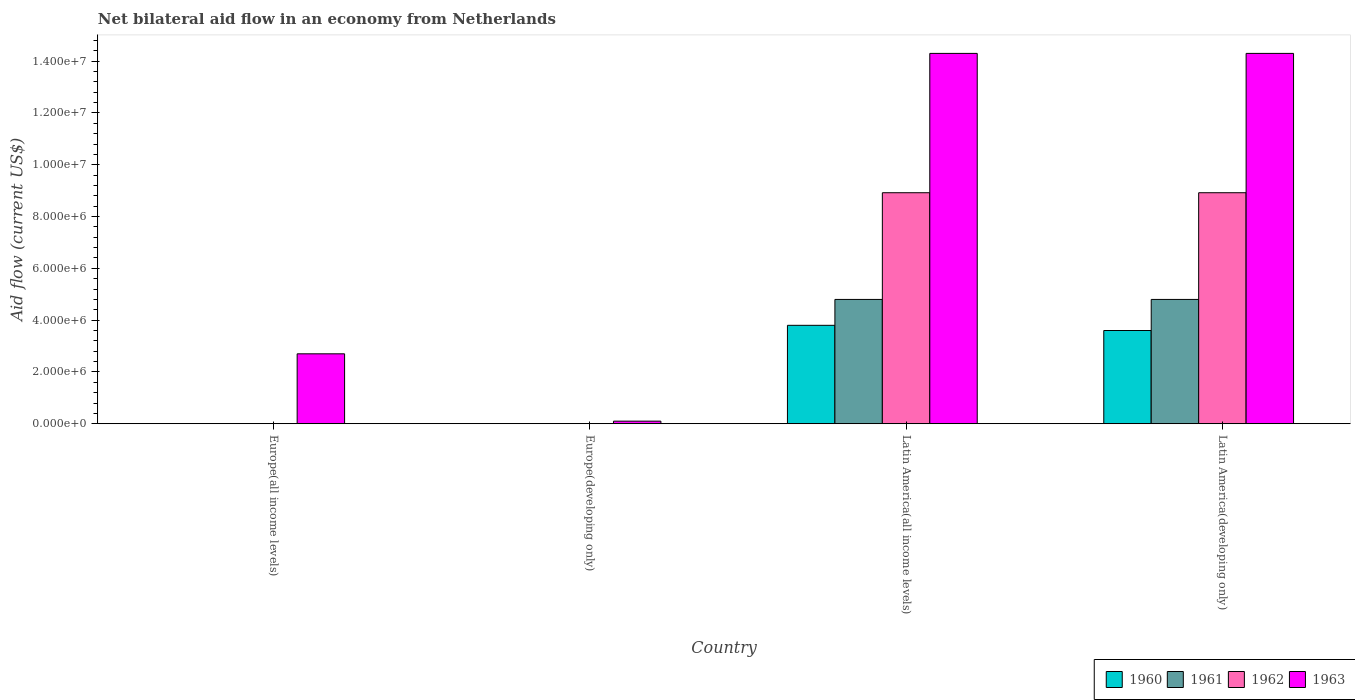Are the number of bars per tick equal to the number of legend labels?
Offer a terse response. No. What is the label of the 2nd group of bars from the left?
Offer a terse response. Europe(developing only). In how many cases, is the number of bars for a given country not equal to the number of legend labels?
Make the answer very short. 2. What is the net bilateral aid flow in 1962 in Latin America(all income levels)?
Give a very brief answer. 8.92e+06. Across all countries, what is the maximum net bilateral aid flow in 1962?
Offer a very short reply. 8.92e+06. In which country was the net bilateral aid flow in 1962 maximum?
Offer a terse response. Latin America(all income levels). What is the total net bilateral aid flow in 1963 in the graph?
Your answer should be very brief. 3.14e+07. What is the difference between the net bilateral aid flow in 1963 in Europe(developing only) and that in Latin America(all income levels)?
Offer a terse response. -1.42e+07. What is the difference between the net bilateral aid flow in 1961 in Latin America(all income levels) and the net bilateral aid flow in 1963 in Latin America(developing only)?
Provide a succinct answer. -9.50e+06. What is the average net bilateral aid flow in 1960 per country?
Give a very brief answer. 1.85e+06. What is the difference between the net bilateral aid flow of/in 1963 and net bilateral aid flow of/in 1962 in Latin America(all income levels)?
Provide a short and direct response. 5.38e+06. What is the ratio of the net bilateral aid flow in 1963 in Europe(developing only) to that in Latin America(all income levels)?
Your answer should be compact. 0.01. What is the difference between the highest and the second highest net bilateral aid flow in 1963?
Provide a succinct answer. 1.16e+07. What is the difference between the highest and the lowest net bilateral aid flow in 1963?
Provide a short and direct response. 1.42e+07. In how many countries, is the net bilateral aid flow in 1962 greater than the average net bilateral aid flow in 1962 taken over all countries?
Provide a short and direct response. 2. Is it the case that in every country, the sum of the net bilateral aid flow in 1962 and net bilateral aid flow in 1961 is greater than the sum of net bilateral aid flow in 1960 and net bilateral aid flow in 1963?
Provide a short and direct response. No. Are the values on the major ticks of Y-axis written in scientific E-notation?
Your answer should be compact. Yes. Does the graph contain any zero values?
Your response must be concise. Yes. Does the graph contain grids?
Provide a succinct answer. No. How many legend labels are there?
Offer a very short reply. 4. How are the legend labels stacked?
Offer a terse response. Horizontal. What is the title of the graph?
Your answer should be very brief. Net bilateral aid flow in an economy from Netherlands. What is the label or title of the Y-axis?
Provide a succinct answer. Aid flow (current US$). What is the Aid flow (current US$) of 1962 in Europe(all income levels)?
Your response must be concise. 0. What is the Aid flow (current US$) in 1963 in Europe(all income levels)?
Provide a succinct answer. 2.70e+06. What is the Aid flow (current US$) of 1960 in Europe(developing only)?
Provide a succinct answer. 0. What is the Aid flow (current US$) in 1961 in Europe(developing only)?
Your answer should be very brief. 0. What is the Aid flow (current US$) of 1962 in Europe(developing only)?
Make the answer very short. 0. What is the Aid flow (current US$) of 1963 in Europe(developing only)?
Make the answer very short. 1.00e+05. What is the Aid flow (current US$) in 1960 in Latin America(all income levels)?
Offer a very short reply. 3.80e+06. What is the Aid flow (current US$) in 1961 in Latin America(all income levels)?
Offer a terse response. 4.80e+06. What is the Aid flow (current US$) in 1962 in Latin America(all income levels)?
Make the answer very short. 8.92e+06. What is the Aid flow (current US$) in 1963 in Latin America(all income levels)?
Your answer should be compact. 1.43e+07. What is the Aid flow (current US$) in 1960 in Latin America(developing only)?
Make the answer very short. 3.60e+06. What is the Aid flow (current US$) of 1961 in Latin America(developing only)?
Give a very brief answer. 4.80e+06. What is the Aid flow (current US$) in 1962 in Latin America(developing only)?
Make the answer very short. 8.92e+06. What is the Aid flow (current US$) of 1963 in Latin America(developing only)?
Offer a terse response. 1.43e+07. Across all countries, what is the maximum Aid flow (current US$) of 1960?
Offer a very short reply. 3.80e+06. Across all countries, what is the maximum Aid flow (current US$) in 1961?
Provide a short and direct response. 4.80e+06. Across all countries, what is the maximum Aid flow (current US$) of 1962?
Your answer should be very brief. 8.92e+06. Across all countries, what is the maximum Aid flow (current US$) in 1963?
Your answer should be compact. 1.43e+07. Across all countries, what is the minimum Aid flow (current US$) of 1962?
Provide a succinct answer. 0. What is the total Aid flow (current US$) in 1960 in the graph?
Offer a terse response. 7.40e+06. What is the total Aid flow (current US$) in 1961 in the graph?
Keep it short and to the point. 9.60e+06. What is the total Aid flow (current US$) in 1962 in the graph?
Your answer should be very brief. 1.78e+07. What is the total Aid flow (current US$) in 1963 in the graph?
Provide a succinct answer. 3.14e+07. What is the difference between the Aid flow (current US$) in 1963 in Europe(all income levels) and that in Europe(developing only)?
Provide a short and direct response. 2.60e+06. What is the difference between the Aid flow (current US$) in 1963 in Europe(all income levels) and that in Latin America(all income levels)?
Make the answer very short. -1.16e+07. What is the difference between the Aid flow (current US$) of 1963 in Europe(all income levels) and that in Latin America(developing only)?
Make the answer very short. -1.16e+07. What is the difference between the Aid flow (current US$) of 1963 in Europe(developing only) and that in Latin America(all income levels)?
Your response must be concise. -1.42e+07. What is the difference between the Aid flow (current US$) in 1963 in Europe(developing only) and that in Latin America(developing only)?
Offer a terse response. -1.42e+07. What is the difference between the Aid flow (current US$) of 1960 in Latin America(all income levels) and that in Latin America(developing only)?
Ensure brevity in your answer.  2.00e+05. What is the difference between the Aid flow (current US$) of 1962 in Latin America(all income levels) and that in Latin America(developing only)?
Give a very brief answer. 0. What is the difference between the Aid flow (current US$) in 1963 in Latin America(all income levels) and that in Latin America(developing only)?
Provide a succinct answer. 0. What is the difference between the Aid flow (current US$) of 1960 in Latin America(all income levels) and the Aid flow (current US$) of 1961 in Latin America(developing only)?
Give a very brief answer. -1.00e+06. What is the difference between the Aid flow (current US$) in 1960 in Latin America(all income levels) and the Aid flow (current US$) in 1962 in Latin America(developing only)?
Your answer should be compact. -5.12e+06. What is the difference between the Aid flow (current US$) in 1960 in Latin America(all income levels) and the Aid flow (current US$) in 1963 in Latin America(developing only)?
Keep it short and to the point. -1.05e+07. What is the difference between the Aid flow (current US$) of 1961 in Latin America(all income levels) and the Aid flow (current US$) of 1962 in Latin America(developing only)?
Make the answer very short. -4.12e+06. What is the difference between the Aid flow (current US$) of 1961 in Latin America(all income levels) and the Aid flow (current US$) of 1963 in Latin America(developing only)?
Give a very brief answer. -9.50e+06. What is the difference between the Aid flow (current US$) in 1962 in Latin America(all income levels) and the Aid flow (current US$) in 1963 in Latin America(developing only)?
Provide a succinct answer. -5.38e+06. What is the average Aid flow (current US$) in 1960 per country?
Your answer should be very brief. 1.85e+06. What is the average Aid flow (current US$) in 1961 per country?
Keep it short and to the point. 2.40e+06. What is the average Aid flow (current US$) of 1962 per country?
Your answer should be compact. 4.46e+06. What is the average Aid flow (current US$) of 1963 per country?
Your answer should be very brief. 7.85e+06. What is the difference between the Aid flow (current US$) of 1960 and Aid flow (current US$) of 1961 in Latin America(all income levels)?
Offer a terse response. -1.00e+06. What is the difference between the Aid flow (current US$) in 1960 and Aid flow (current US$) in 1962 in Latin America(all income levels)?
Keep it short and to the point. -5.12e+06. What is the difference between the Aid flow (current US$) in 1960 and Aid flow (current US$) in 1963 in Latin America(all income levels)?
Keep it short and to the point. -1.05e+07. What is the difference between the Aid flow (current US$) in 1961 and Aid flow (current US$) in 1962 in Latin America(all income levels)?
Your answer should be very brief. -4.12e+06. What is the difference between the Aid flow (current US$) of 1961 and Aid flow (current US$) of 1963 in Latin America(all income levels)?
Offer a very short reply. -9.50e+06. What is the difference between the Aid flow (current US$) in 1962 and Aid flow (current US$) in 1963 in Latin America(all income levels)?
Your answer should be very brief. -5.38e+06. What is the difference between the Aid flow (current US$) in 1960 and Aid flow (current US$) in 1961 in Latin America(developing only)?
Your answer should be compact. -1.20e+06. What is the difference between the Aid flow (current US$) in 1960 and Aid flow (current US$) in 1962 in Latin America(developing only)?
Offer a very short reply. -5.32e+06. What is the difference between the Aid flow (current US$) in 1960 and Aid flow (current US$) in 1963 in Latin America(developing only)?
Keep it short and to the point. -1.07e+07. What is the difference between the Aid flow (current US$) in 1961 and Aid flow (current US$) in 1962 in Latin America(developing only)?
Your answer should be compact. -4.12e+06. What is the difference between the Aid flow (current US$) of 1961 and Aid flow (current US$) of 1963 in Latin America(developing only)?
Offer a terse response. -9.50e+06. What is the difference between the Aid flow (current US$) in 1962 and Aid flow (current US$) in 1963 in Latin America(developing only)?
Offer a terse response. -5.38e+06. What is the ratio of the Aid flow (current US$) in 1963 in Europe(all income levels) to that in Latin America(all income levels)?
Make the answer very short. 0.19. What is the ratio of the Aid flow (current US$) in 1963 in Europe(all income levels) to that in Latin America(developing only)?
Your answer should be compact. 0.19. What is the ratio of the Aid flow (current US$) in 1963 in Europe(developing only) to that in Latin America(all income levels)?
Provide a succinct answer. 0.01. What is the ratio of the Aid flow (current US$) in 1963 in Europe(developing only) to that in Latin America(developing only)?
Make the answer very short. 0.01. What is the ratio of the Aid flow (current US$) in 1960 in Latin America(all income levels) to that in Latin America(developing only)?
Your answer should be compact. 1.06. What is the ratio of the Aid flow (current US$) in 1961 in Latin America(all income levels) to that in Latin America(developing only)?
Give a very brief answer. 1. What is the difference between the highest and the second highest Aid flow (current US$) in 1963?
Your response must be concise. 0. What is the difference between the highest and the lowest Aid flow (current US$) in 1960?
Your answer should be compact. 3.80e+06. What is the difference between the highest and the lowest Aid flow (current US$) of 1961?
Offer a very short reply. 4.80e+06. What is the difference between the highest and the lowest Aid flow (current US$) of 1962?
Provide a short and direct response. 8.92e+06. What is the difference between the highest and the lowest Aid flow (current US$) in 1963?
Give a very brief answer. 1.42e+07. 